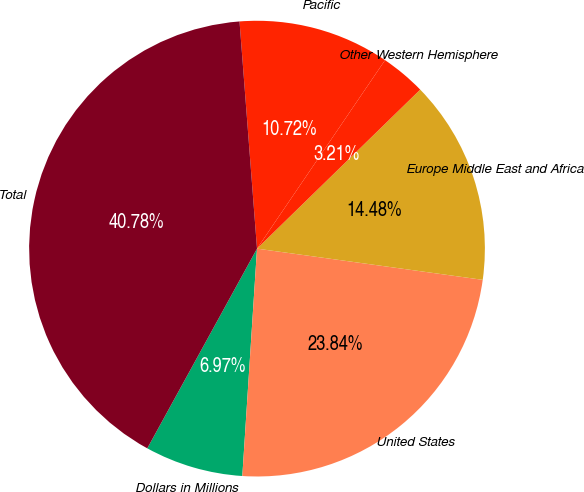Convert chart. <chart><loc_0><loc_0><loc_500><loc_500><pie_chart><fcel>Dollars in Millions<fcel>United States<fcel>Europe Middle East and Africa<fcel>Other Western Hemisphere<fcel>Pacific<fcel>Total<nl><fcel>6.97%<fcel>23.84%<fcel>14.48%<fcel>3.21%<fcel>10.72%<fcel>40.78%<nl></chart> 